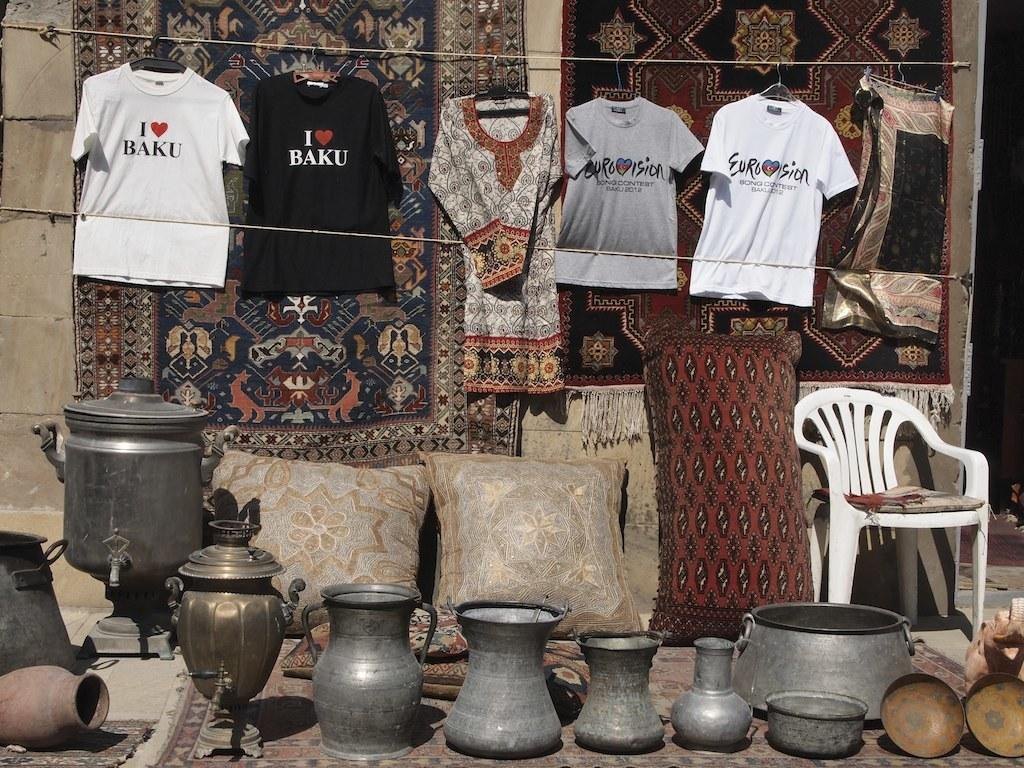<image>
Summarize the visual content of the image. the word eurosion that is on a t shirt 